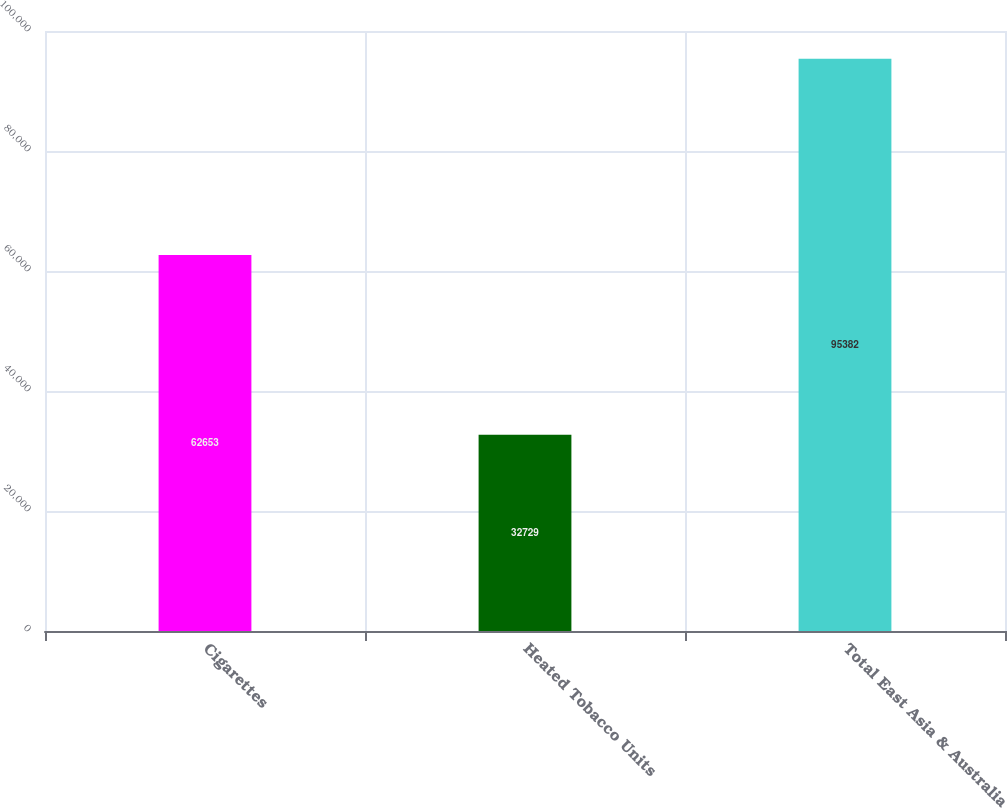<chart> <loc_0><loc_0><loc_500><loc_500><bar_chart><fcel>Cigarettes<fcel>Heated Tobacco Units<fcel>Total East Asia & Australia<nl><fcel>62653<fcel>32729<fcel>95382<nl></chart> 